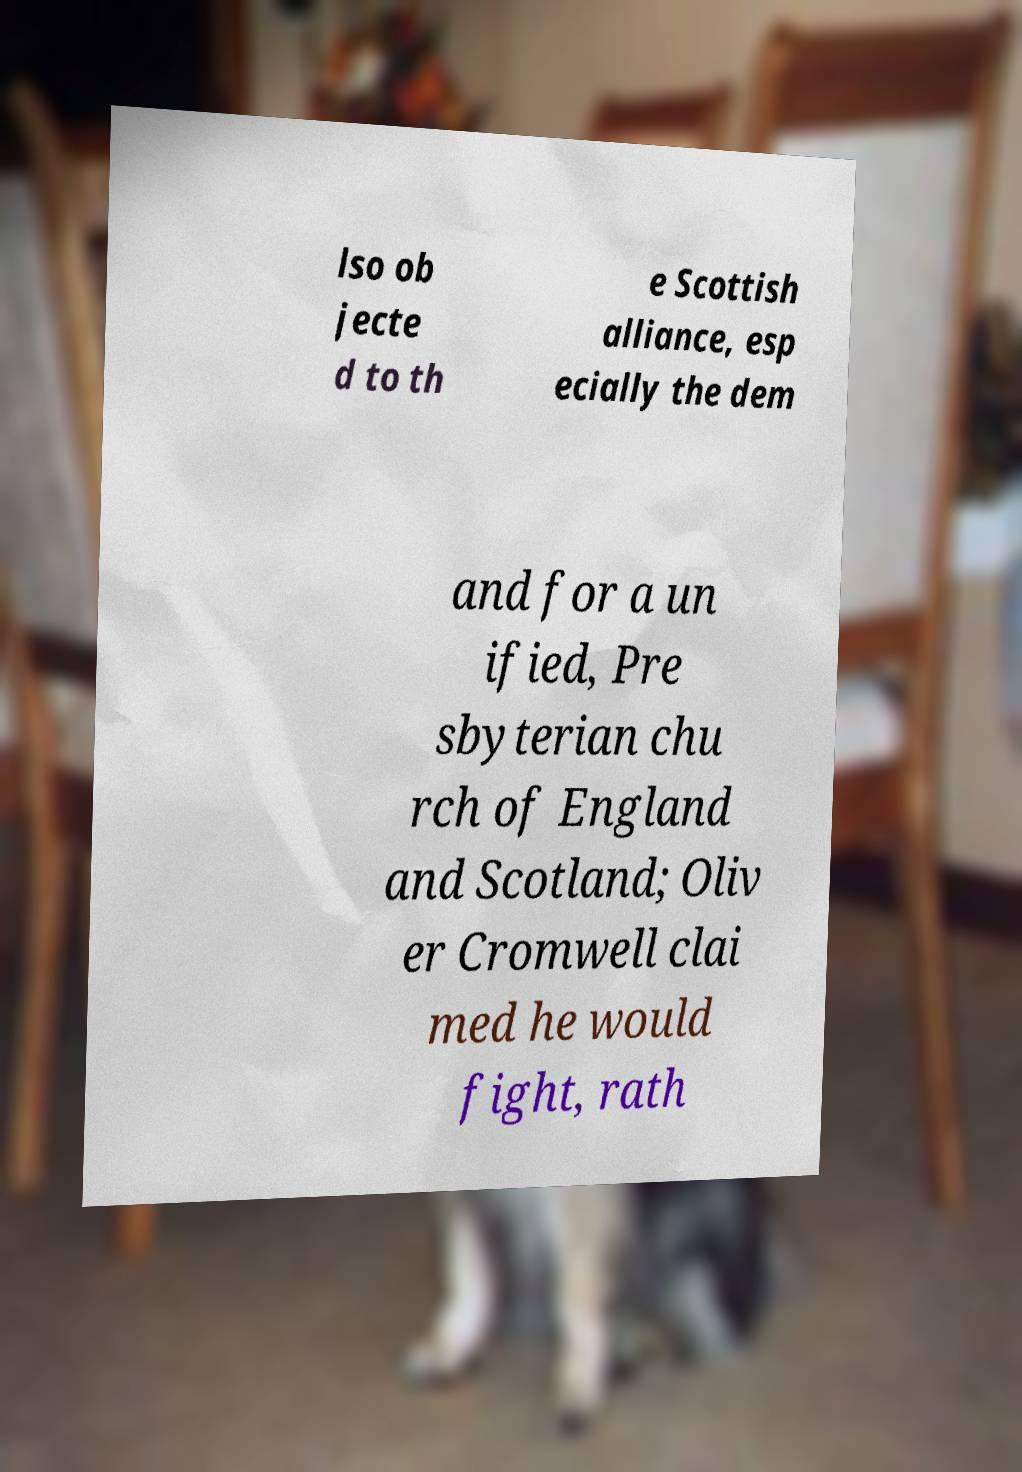I need the written content from this picture converted into text. Can you do that? lso ob jecte d to th e Scottish alliance, esp ecially the dem and for a un ified, Pre sbyterian chu rch of England and Scotland; Oliv er Cromwell clai med he would fight, rath 